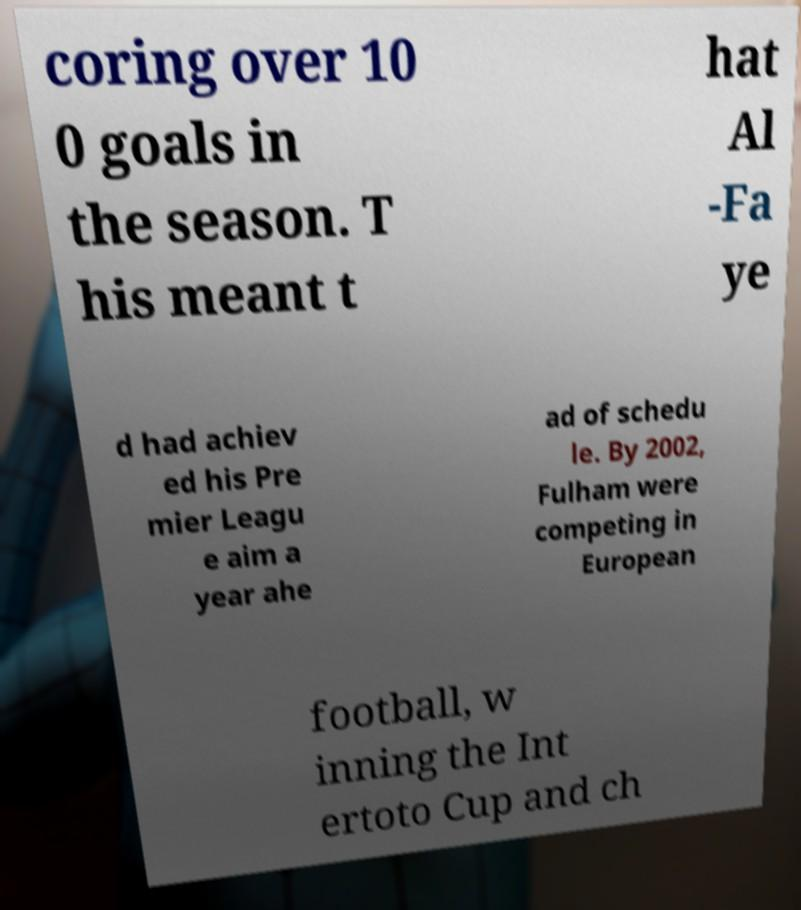Can you accurately transcribe the text from the provided image for me? coring over 10 0 goals in the season. T his meant t hat Al -Fa ye d had achiev ed his Pre mier Leagu e aim a year ahe ad of schedu le. By 2002, Fulham were competing in European football, w inning the Int ertoto Cup and ch 